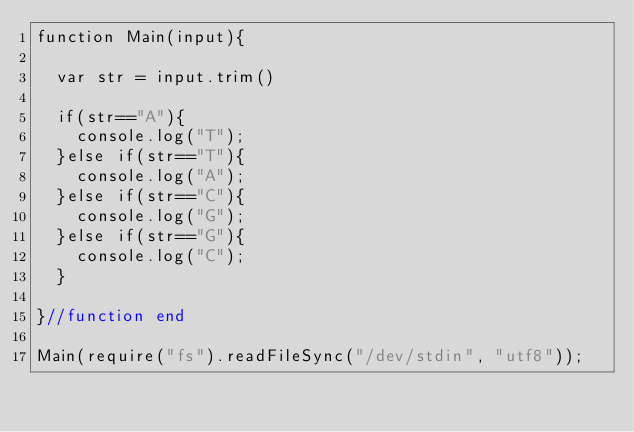Convert code to text. <code><loc_0><loc_0><loc_500><loc_500><_JavaScript_>function Main(input){
  
  var str = input.trim()
  
  if(str=="A"){
    console.log("T");
  }else if(str=="T"){
    console.log("A");
  }else if(str=="C"){
    console.log("G");
  }else if(str=="G"){
    console.log("C");
  }
 
}//function end
 
Main(require("fs").readFileSync("/dev/stdin", "utf8"));</code> 